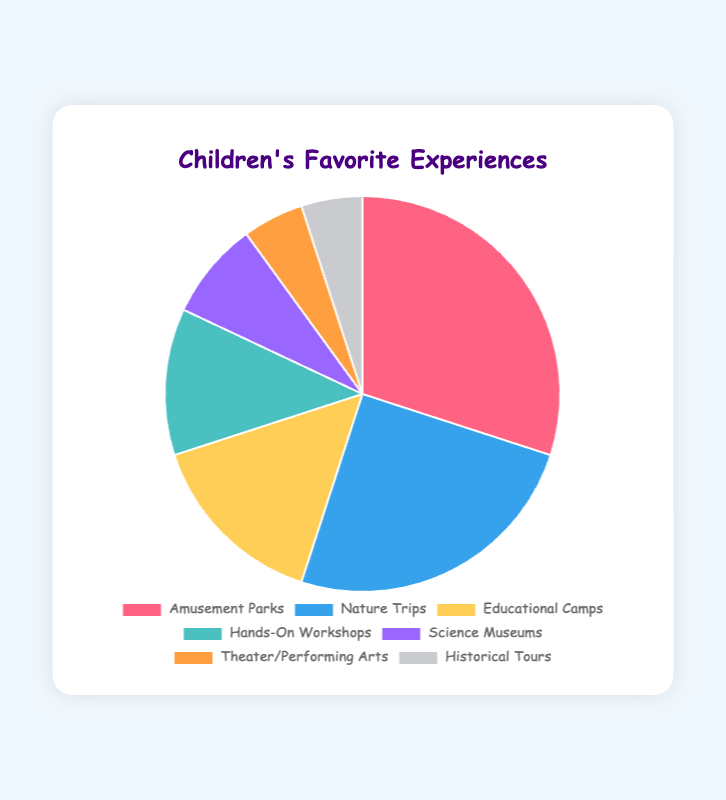What percentage of children prefer Nature Trips compared to those who prefer Historical Tours? Nature Trips are 25% and Historical Tours are 5%. To compare, divide 25 by 5, resulting in 25/5 = 5. So, children who prefer Nature Trips are 5 times more compared to Historical Tours.
Answer: 5 times What's the sum of the percentages for children who favor Science Museums and Theater/Performing Arts? Science Museums are 8% and Theater/Performing Arts are 5%. Summing these percentages gives 8 + 5 = 13.
Answer: 13% How many more children prefer Amusement Parks over Hands-On Workshops? The percentage for Amusement Parks is 30% and Hands-On Workshops is 12%. The difference is 30 - 12 = 18.
Answer: 18% Which experience has the second highest percentage of children's preference and what is it? The highest percentage is for Amusement Parks at 30%, and the second highest is Nature Trips at 25%.
Answer: Nature Trips, 25% Is the combined percentage of children preferring Educational Camps and Hands-On Workshops greater than those favoring Amusement Parks? Educational Camps are 15% and Hands-On Workshops are 12%. Their combined percentage is 15 + 12 = 27%, which is less than 30% for Amusement Parks.
Answer: No What is the least favored experience among children and what percentage does it represent? The least favored experiences are Theater/Performing Arts and Historical Tours, each representing 5%.
Answer: Theater/Performing Arts and Historical Tours, 5% Between Science Museums and Nature Trips, which experience has higher preference, and by how much? Science Museums are 8% and Nature Trips are 25%. The difference is 25 - 8 = 17.
Answer: Nature Trips, by 17% What is the average percentage of preference for Nature Trips, Educational Camps, and Hands-On Workshops? Nature Trips are 25%, Educational Camps are 15%, and Hands-On Workshops are 12%. Their total percentage is 25 + 15 + 12 = 52%. Dividing by 3 gives 52/3 ≈ 17.33.
Answer: 17.33% If you combine the percentages of Theater/Performing Arts, Historical Tours, and Science Museums, does the sum exceed the percentage for Nature Trips? Theater/Performing Arts are 5%, Historical Tours are 5%, and Science Museums are 8%. Combined, they make 5 + 5 + 8 = 18%, which is less than 25% for Nature Trips.
Answer: No Which experience is represented by the color resembling red in the pie chart, and what percentage does it hold? The segment colored with red corresponds to Amusement Parks, which holds 30%.
Answer: Amusement Parks, 30% 